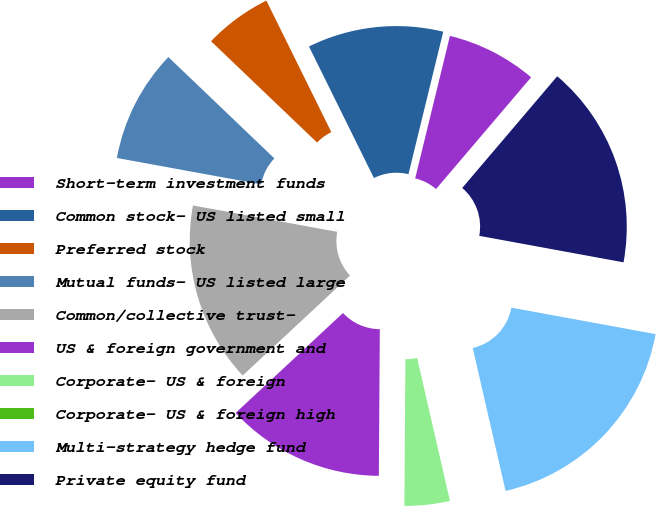Convert chart. <chart><loc_0><loc_0><loc_500><loc_500><pie_chart><fcel>Short-term investment funds<fcel>Common stock- US listed small<fcel>Preferred stock<fcel>Mutual funds- US listed large<fcel>Common/collective trust-<fcel>US & foreign government and<fcel>Corporate- US & foreign<fcel>Corporate- US & foreign high<fcel>Multi-strategy hedge fund<fcel>Private equity fund<nl><fcel>7.41%<fcel>11.11%<fcel>5.56%<fcel>9.26%<fcel>14.81%<fcel>12.96%<fcel>3.7%<fcel>0.0%<fcel>18.52%<fcel>16.67%<nl></chart> 